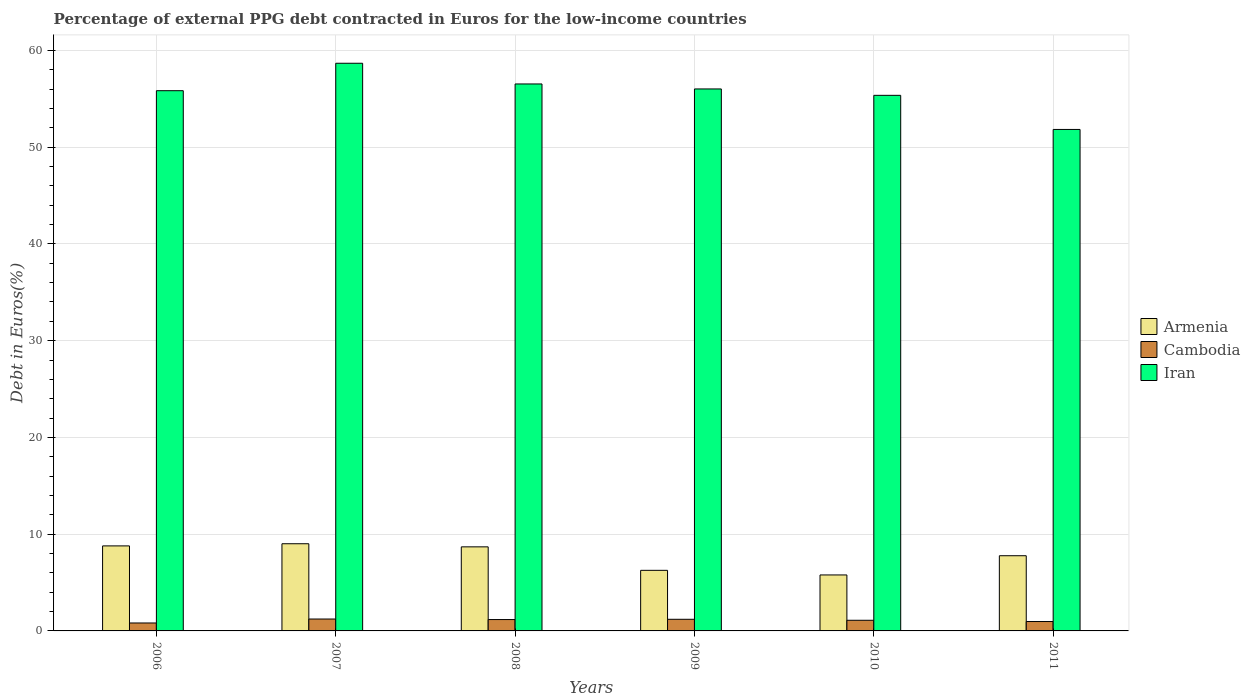How many groups of bars are there?
Give a very brief answer. 6. Are the number of bars per tick equal to the number of legend labels?
Provide a succinct answer. Yes. Are the number of bars on each tick of the X-axis equal?
Ensure brevity in your answer.  Yes. How many bars are there on the 6th tick from the right?
Ensure brevity in your answer.  3. What is the label of the 2nd group of bars from the left?
Provide a succinct answer. 2007. In how many cases, is the number of bars for a given year not equal to the number of legend labels?
Your response must be concise. 0. What is the percentage of external PPG debt contracted in Euros in Armenia in 2007?
Provide a succinct answer. 9.01. Across all years, what is the maximum percentage of external PPG debt contracted in Euros in Iran?
Give a very brief answer. 58.67. Across all years, what is the minimum percentage of external PPG debt contracted in Euros in Armenia?
Offer a terse response. 5.78. What is the total percentage of external PPG debt contracted in Euros in Iran in the graph?
Your answer should be compact. 334.23. What is the difference between the percentage of external PPG debt contracted in Euros in Cambodia in 2006 and that in 2007?
Your response must be concise. -0.41. What is the difference between the percentage of external PPG debt contracted in Euros in Cambodia in 2007 and the percentage of external PPG debt contracted in Euros in Iran in 2010?
Provide a succinct answer. -54.12. What is the average percentage of external PPG debt contracted in Euros in Armenia per year?
Keep it short and to the point. 7.72. In the year 2011, what is the difference between the percentage of external PPG debt contracted in Euros in Armenia and percentage of external PPG debt contracted in Euros in Iran?
Offer a very short reply. -44.06. What is the ratio of the percentage of external PPG debt contracted in Euros in Iran in 2008 to that in 2009?
Make the answer very short. 1.01. Is the difference between the percentage of external PPG debt contracted in Euros in Armenia in 2008 and 2011 greater than the difference between the percentage of external PPG debt contracted in Euros in Iran in 2008 and 2011?
Keep it short and to the point. No. What is the difference between the highest and the second highest percentage of external PPG debt contracted in Euros in Armenia?
Keep it short and to the point. 0.22. What is the difference between the highest and the lowest percentage of external PPG debt contracted in Euros in Iran?
Offer a terse response. 6.84. In how many years, is the percentage of external PPG debt contracted in Euros in Iran greater than the average percentage of external PPG debt contracted in Euros in Iran taken over all years?
Ensure brevity in your answer.  4. What does the 1st bar from the left in 2009 represents?
Your answer should be compact. Armenia. What does the 1st bar from the right in 2006 represents?
Keep it short and to the point. Iran. How many years are there in the graph?
Ensure brevity in your answer.  6. Are the values on the major ticks of Y-axis written in scientific E-notation?
Offer a terse response. No. Does the graph contain any zero values?
Your answer should be compact. No. How many legend labels are there?
Provide a short and direct response. 3. What is the title of the graph?
Your answer should be compact. Percentage of external PPG debt contracted in Euros for the low-income countries. What is the label or title of the X-axis?
Your answer should be very brief. Years. What is the label or title of the Y-axis?
Offer a terse response. Debt in Euros(%). What is the Debt in Euros(%) of Armenia in 2006?
Provide a succinct answer. 8.79. What is the Debt in Euros(%) in Cambodia in 2006?
Make the answer very short. 0.82. What is the Debt in Euros(%) in Iran in 2006?
Ensure brevity in your answer.  55.83. What is the Debt in Euros(%) of Armenia in 2007?
Ensure brevity in your answer.  9.01. What is the Debt in Euros(%) in Cambodia in 2007?
Give a very brief answer. 1.23. What is the Debt in Euros(%) in Iran in 2007?
Make the answer very short. 58.67. What is the Debt in Euros(%) of Armenia in 2008?
Give a very brief answer. 8.69. What is the Debt in Euros(%) of Cambodia in 2008?
Ensure brevity in your answer.  1.18. What is the Debt in Euros(%) in Iran in 2008?
Provide a short and direct response. 56.53. What is the Debt in Euros(%) in Armenia in 2009?
Offer a terse response. 6.26. What is the Debt in Euros(%) of Cambodia in 2009?
Keep it short and to the point. 1.2. What is the Debt in Euros(%) in Iran in 2009?
Make the answer very short. 56.01. What is the Debt in Euros(%) of Armenia in 2010?
Provide a succinct answer. 5.78. What is the Debt in Euros(%) in Cambodia in 2010?
Make the answer very short. 1.1. What is the Debt in Euros(%) of Iran in 2010?
Give a very brief answer. 55.35. What is the Debt in Euros(%) of Armenia in 2011?
Give a very brief answer. 7.77. What is the Debt in Euros(%) in Cambodia in 2011?
Keep it short and to the point. 0.97. What is the Debt in Euros(%) of Iran in 2011?
Offer a very short reply. 51.83. Across all years, what is the maximum Debt in Euros(%) in Armenia?
Offer a very short reply. 9.01. Across all years, what is the maximum Debt in Euros(%) of Cambodia?
Keep it short and to the point. 1.23. Across all years, what is the maximum Debt in Euros(%) in Iran?
Your answer should be compact. 58.67. Across all years, what is the minimum Debt in Euros(%) of Armenia?
Keep it short and to the point. 5.78. Across all years, what is the minimum Debt in Euros(%) in Cambodia?
Your answer should be very brief. 0.82. Across all years, what is the minimum Debt in Euros(%) of Iran?
Give a very brief answer. 51.83. What is the total Debt in Euros(%) in Armenia in the graph?
Provide a short and direct response. 46.31. What is the total Debt in Euros(%) in Cambodia in the graph?
Ensure brevity in your answer.  6.5. What is the total Debt in Euros(%) in Iran in the graph?
Give a very brief answer. 334.23. What is the difference between the Debt in Euros(%) in Armenia in 2006 and that in 2007?
Provide a short and direct response. -0.22. What is the difference between the Debt in Euros(%) of Cambodia in 2006 and that in 2007?
Provide a short and direct response. -0.41. What is the difference between the Debt in Euros(%) of Iran in 2006 and that in 2007?
Make the answer very short. -2.84. What is the difference between the Debt in Euros(%) of Armenia in 2006 and that in 2008?
Offer a terse response. 0.1. What is the difference between the Debt in Euros(%) in Cambodia in 2006 and that in 2008?
Your response must be concise. -0.35. What is the difference between the Debt in Euros(%) of Iran in 2006 and that in 2008?
Ensure brevity in your answer.  -0.7. What is the difference between the Debt in Euros(%) in Armenia in 2006 and that in 2009?
Provide a succinct answer. 2.53. What is the difference between the Debt in Euros(%) of Cambodia in 2006 and that in 2009?
Your answer should be very brief. -0.38. What is the difference between the Debt in Euros(%) of Iran in 2006 and that in 2009?
Ensure brevity in your answer.  -0.18. What is the difference between the Debt in Euros(%) of Armenia in 2006 and that in 2010?
Provide a short and direct response. 3. What is the difference between the Debt in Euros(%) of Cambodia in 2006 and that in 2010?
Your answer should be very brief. -0.28. What is the difference between the Debt in Euros(%) in Iran in 2006 and that in 2010?
Keep it short and to the point. 0.48. What is the difference between the Debt in Euros(%) of Armenia in 2006 and that in 2011?
Offer a very short reply. 1.02. What is the difference between the Debt in Euros(%) in Cambodia in 2006 and that in 2011?
Ensure brevity in your answer.  -0.15. What is the difference between the Debt in Euros(%) in Iran in 2006 and that in 2011?
Ensure brevity in your answer.  4.01. What is the difference between the Debt in Euros(%) of Armenia in 2007 and that in 2008?
Your response must be concise. 0.32. What is the difference between the Debt in Euros(%) of Cambodia in 2007 and that in 2008?
Provide a succinct answer. 0.05. What is the difference between the Debt in Euros(%) in Iran in 2007 and that in 2008?
Provide a short and direct response. 2.14. What is the difference between the Debt in Euros(%) of Armenia in 2007 and that in 2009?
Your answer should be very brief. 2.75. What is the difference between the Debt in Euros(%) of Cambodia in 2007 and that in 2009?
Provide a succinct answer. 0.03. What is the difference between the Debt in Euros(%) in Iran in 2007 and that in 2009?
Provide a short and direct response. 2.66. What is the difference between the Debt in Euros(%) of Armenia in 2007 and that in 2010?
Offer a very short reply. 3.23. What is the difference between the Debt in Euros(%) in Cambodia in 2007 and that in 2010?
Provide a short and direct response. 0.13. What is the difference between the Debt in Euros(%) in Iran in 2007 and that in 2010?
Your answer should be compact. 3.32. What is the difference between the Debt in Euros(%) in Armenia in 2007 and that in 2011?
Offer a terse response. 1.24. What is the difference between the Debt in Euros(%) of Cambodia in 2007 and that in 2011?
Make the answer very short. 0.26. What is the difference between the Debt in Euros(%) of Iran in 2007 and that in 2011?
Keep it short and to the point. 6.84. What is the difference between the Debt in Euros(%) of Armenia in 2008 and that in 2009?
Ensure brevity in your answer.  2.43. What is the difference between the Debt in Euros(%) of Cambodia in 2008 and that in 2009?
Keep it short and to the point. -0.03. What is the difference between the Debt in Euros(%) in Iran in 2008 and that in 2009?
Your response must be concise. 0.52. What is the difference between the Debt in Euros(%) of Armenia in 2008 and that in 2010?
Your answer should be very brief. 2.9. What is the difference between the Debt in Euros(%) in Cambodia in 2008 and that in 2010?
Provide a short and direct response. 0.07. What is the difference between the Debt in Euros(%) of Iran in 2008 and that in 2010?
Your answer should be compact. 1.18. What is the difference between the Debt in Euros(%) of Armenia in 2008 and that in 2011?
Ensure brevity in your answer.  0.92. What is the difference between the Debt in Euros(%) of Cambodia in 2008 and that in 2011?
Your response must be concise. 0.2. What is the difference between the Debt in Euros(%) of Iran in 2008 and that in 2011?
Ensure brevity in your answer.  4.7. What is the difference between the Debt in Euros(%) of Armenia in 2009 and that in 2010?
Your response must be concise. 0.48. What is the difference between the Debt in Euros(%) in Cambodia in 2009 and that in 2010?
Provide a short and direct response. 0.1. What is the difference between the Debt in Euros(%) in Iran in 2009 and that in 2010?
Offer a terse response. 0.66. What is the difference between the Debt in Euros(%) of Armenia in 2009 and that in 2011?
Provide a short and direct response. -1.51. What is the difference between the Debt in Euros(%) in Cambodia in 2009 and that in 2011?
Offer a very short reply. 0.23. What is the difference between the Debt in Euros(%) in Iran in 2009 and that in 2011?
Ensure brevity in your answer.  4.19. What is the difference between the Debt in Euros(%) in Armenia in 2010 and that in 2011?
Offer a very short reply. -1.99. What is the difference between the Debt in Euros(%) in Cambodia in 2010 and that in 2011?
Provide a succinct answer. 0.13. What is the difference between the Debt in Euros(%) in Iran in 2010 and that in 2011?
Offer a very short reply. 3.53. What is the difference between the Debt in Euros(%) in Armenia in 2006 and the Debt in Euros(%) in Cambodia in 2007?
Keep it short and to the point. 7.56. What is the difference between the Debt in Euros(%) in Armenia in 2006 and the Debt in Euros(%) in Iran in 2007?
Offer a very short reply. -49.88. What is the difference between the Debt in Euros(%) in Cambodia in 2006 and the Debt in Euros(%) in Iran in 2007?
Ensure brevity in your answer.  -57.85. What is the difference between the Debt in Euros(%) in Armenia in 2006 and the Debt in Euros(%) in Cambodia in 2008?
Your answer should be compact. 7.61. What is the difference between the Debt in Euros(%) in Armenia in 2006 and the Debt in Euros(%) in Iran in 2008?
Provide a succinct answer. -47.74. What is the difference between the Debt in Euros(%) of Cambodia in 2006 and the Debt in Euros(%) of Iran in 2008?
Offer a very short reply. -55.71. What is the difference between the Debt in Euros(%) in Armenia in 2006 and the Debt in Euros(%) in Cambodia in 2009?
Make the answer very short. 7.59. What is the difference between the Debt in Euros(%) in Armenia in 2006 and the Debt in Euros(%) in Iran in 2009?
Offer a terse response. -47.23. What is the difference between the Debt in Euros(%) of Cambodia in 2006 and the Debt in Euros(%) of Iran in 2009?
Your answer should be compact. -55.19. What is the difference between the Debt in Euros(%) in Armenia in 2006 and the Debt in Euros(%) in Cambodia in 2010?
Give a very brief answer. 7.69. What is the difference between the Debt in Euros(%) of Armenia in 2006 and the Debt in Euros(%) of Iran in 2010?
Make the answer very short. -46.57. What is the difference between the Debt in Euros(%) in Cambodia in 2006 and the Debt in Euros(%) in Iran in 2010?
Keep it short and to the point. -54.53. What is the difference between the Debt in Euros(%) of Armenia in 2006 and the Debt in Euros(%) of Cambodia in 2011?
Provide a short and direct response. 7.82. What is the difference between the Debt in Euros(%) in Armenia in 2006 and the Debt in Euros(%) in Iran in 2011?
Keep it short and to the point. -43.04. What is the difference between the Debt in Euros(%) of Cambodia in 2006 and the Debt in Euros(%) of Iran in 2011?
Give a very brief answer. -51.01. What is the difference between the Debt in Euros(%) in Armenia in 2007 and the Debt in Euros(%) in Cambodia in 2008?
Make the answer very short. 7.84. What is the difference between the Debt in Euros(%) in Armenia in 2007 and the Debt in Euros(%) in Iran in 2008?
Your response must be concise. -47.52. What is the difference between the Debt in Euros(%) of Cambodia in 2007 and the Debt in Euros(%) of Iran in 2008?
Make the answer very short. -55.3. What is the difference between the Debt in Euros(%) in Armenia in 2007 and the Debt in Euros(%) in Cambodia in 2009?
Your answer should be compact. 7.81. What is the difference between the Debt in Euros(%) of Armenia in 2007 and the Debt in Euros(%) of Iran in 2009?
Give a very brief answer. -47. What is the difference between the Debt in Euros(%) in Cambodia in 2007 and the Debt in Euros(%) in Iran in 2009?
Provide a succinct answer. -54.78. What is the difference between the Debt in Euros(%) in Armenia in 2007 and the Debt in Euros(%) in Cambodia in 2010?
Provide a short and direct response. 7.91. What is the difference between the Debt in Euros(%) in Armenia in 2007 and the Debt in Euros(%) in Iran in 2010?
Provide a short and direct response. -46.34. What is the difference between the Debt in Euros(%) of Cambodia in 2007 and the Debt in Euros(%) of Iran in 2010?
Your answer should be very brief. -54.12. What is the difference between the Debt in Euros(%) of Armenia in 2007 and the Debt in Euros(%) of Cambodia in 2011?
Provide a short and direct response. 8.04. What is the difference between the Debt in Euros(%) in Armenia in 2007 and the Debt in Euros(%) in Iran in 2011?
Provide a succinct answer. -42.82. What is the difference between the Debt in Euros(%) in Cambodia in 2007 and the Debt in Euros(%) in Iran in 2011?
Offer a very short reply. -50.6. What is the difference between the Debt in Euros(%) of Armenia in 2008 and the Debt in Euros(%) of Cambodia in 2009?
Your answer should be compact. 7.49. What is the difference between the Debt in Euros(%) in Armenia in 2008 and the Debt in Euros(%) in Iran in 2009?
Offer a very short reply. -47.33. What is the difference between the Debt in Euros(%) in Cambodia in 2008 and the Debt in Euros(%) in Iran in 2009?
Your answer should be compact. -54.84. What is the difference between the Debt in Euros(%) in Armenia in 2008 and the Debt in Euros(%) in Cambodia in 2010?
Your answer should be very brief. 7.59. What is the difference between the Debt in Euros(%) of Armenia in 2008 and the Debt in Euros(%) of Iran in 2010?
Offer a very short reply. -46.67. What is the difference between the Debt in Euros(%) in Cambodia in 2008 and the Debt in Euros(%) in Iran in 2010?
Provide a succinct answer. -54.18. What is the difference between the Debt in Euros(%) in Armenia in 2008 and the Debt in Euros(%) in Cambodia in 2011?
Keep it short and to the point. 7.72. What is the difference between the Debt in Euros(%) in Armenia in 2008 and the Debt in Euros(%) in Iran in 2011?
Make the answer very short. -43.14. What is the difference between the Debt in Euros(%) in Cambodia in 2008 and the Debt in Euros(%) in Iran in 2011?
Your answer should be compact. -50.65. What is the difference between the Debt in Euros(%) of Armenia in 2009 and the Debt in Euros(%) of Cambodia in 2010?
Your response must be concise. 5.16. What is the difference between the Debt in Euros(%) of Armenia in 2009 and the Debt in Euros(%) of Iran in 2010?
Give a very brief answer. -49.09. What is the difference between the Debt in Euros(%) in Cambodia in 2009 and the Debt in Euros(%) in Iran in 2010?
Give a very brief answer. -54.15. What is the difference between the Debt in Euros(%) in Armenia in 2009 and the Debt in Euros(%) in Cambodia in 2011?
Offer a terse response. 5.29. What is the difference between the Debt in Euros(%) of Armenia in 2009 and the Debt in Euros(%) of Iran in 2011?
Provide a succinct answer. -45.57. What is the difference between the Debt in Euros(%) in Cambodia in 2009 and the Debt in Euros(%) in Iran in 2011?
Your answer should be compact. -50.63. What is the difference between the Debt in Euros(%) in Armenia in 2010 and the Debt in Euros(%) in Cambodia in 2011?
Your response must be concise. 4.81. What is the difference between the Debt in Euros(%) in Armenia in 2010 and the Debt in Euros(%) in Iran in 2011?
Make the answer very short. -46.04. What is the difference between the Debt in Euros(%) of Cambodia in 2010 and the Debt in Euros(%) of Iran in 2011?
Offer a terse response. -50.73. What is the average Debt in Euros(%) of Armenia per year?
Provide a succinct answer. 7.72. What is the average Debt in Euros(%) of Cambodia per year?
Keep it short and to the point. 1.08. What is the average Debt in Euros(%) in Iran per year?
Keep it short and to the point. 55.7. In the year 2006, what is the difference between the Debt in Euros(%) in Armenia and Debt in Euros(%) in Cambodia?
Provide a succinct answer. 7.97. In the year 2006, what is the difference between the Debt in Euros(%) of Armenia and Debt in Euros(%) of Iran?
Your answer should be very brief. -47.05. In the year 2006, what is the difference between the Debt in Euros(%) of Cambodia and Debt in Euros(%) of Iran?
Make the answer very short. -55.01. In the year 2007, what is the difference between the Debt in Euros(%) of Armenia and Debt in Euros(%) of Cambodia?
Give a very brief answer. 7.78. In the year 2007, what is the difference between the Debt in Euros(%) of Armenia and Debt in Euros(%) of Iran?
Offer a very short reply. -49.66. In the year 2007, what is the difference between the Debt in Euros(%) in Cambodia and Debt in Euros(%) in Iran?
Provide a short and direct response. -57.44. In the year 2008, what is the difference between the Debt in Euros(%) in Armenia and Debt in Euros(%) in Cambodia?
Make the answer very short. 7.51. In the year 2008, what is the difference between the Debt in Euros(%) of Armenia and Debt in Euros(%) of Iran?
Keep it short and to the point. -47.84. In the year 2008, what is the difference between the Debt in Euros(%) in Cambodia and Debt in Euros(%) in Iran?
Offer a terse response. -55.36. In the year 2009, what is the difference between the Debt in Euros(%) in Armenia and Debt in Euros(%) in Cambodia?
Your response must be concise. 5.06. In the year 2009, what is the difference between the Debt in Euros(%) in Armenia and Debt in Euros(%) in Iran?
Your answer should be very brief. -49.75. In the year 2009, what is the difference between the Debt in Euros(%) of Cambodia and Debt in Euros(%) of Iran?
Provide a succinct answer. -54.81. In the year 2010, what is the difference between the Debt in Euros(%) in Armenia and Debt in Euros(%) in Cambodia?
Provide a succinct answer. 4.68. In the year 2010, what is the difference between the Debt in Euros(%) in Armenia and Debt in Euros(%) in Iran?
Offer a very short reply. -49.57. In the year 2010, what is the difference between the Debt in Euros(%) of Cambodia and Debt in Euros(%) of Iran?
Give a very brief answer. -54.25. In the year 2011, what is the difference between the Debt in Euros(%) of Armenia and Debt in Euros(%) of Cambodia?
Your answer should be very brief. 6.8. In the year 2011, what is the difference between the Debt in Euros(%) of Armenia and Debt in Euros(%) of Iran?
Your response must be concise. -44.06. In the year 2011, what is the difference between the Debt in Euros(%) of Cambodia and Debt in Euros(%) of Iran?
Keep it short and to the point. -50.86. What is the ratio of the Debt in Euros(%) of Armenia in 2006 to that in 2007?
Offer a very short reply. 0.98. What is the ratio of the Debt in Euros(%) in Cambodia in 2006 to that in 2007?
Provide a short and direct response. 0.67. What is the ratio of the Debt in Euros(%) in Iran in 2006 to that in 2007?
Provide a succinct answer. 0.95. What is the ratio of the Debt in Euros(%) in Armenia in 2006 to that in 2008?
Your answer should be compact. 1.01. What is the ratio of the Debt in Euros(%) of Cambodia in 2006 to that in 2008?
Ensure brevity in your answer.  0.7. What is the ratio of the Debt in Euros(%) of Iran in 2006 to that in 2008?
Your answer should be compact. 0.99. What is the ratio of the Debt in Euros(%) in Armenia in 2006 to that in 2009?
Ensure brevity in your answer.  1.4. What is the ratio of the Debt in Euros(%) of Cambodia in 2006 to that in 2009?
Ensure brevity in your answer.  0.68. What is the ratio of the Debt in Euros(%) in Iran in 2006 to that in 2009?
Make the answer very short. 1. What is the ratio of the Debt in Euros(%) of Armenia in 2006 to that in 2010?
Provide a succinct answer. 1.52. What is the ratio of the Debt in Euros(%) of Cambodia in 2006 to that in 2010?
Provide a short and direct response. 0.75. What is the ratio of the Debt in Euros(%) in Iran in 2006 to that in 2010?
Ensure brevity in your answer.  1.01. What is the ratio of the Debt in Euros(%) in Armenia in 2006 to that in 2011?
Provide a short and direct response. 1.13. What is the ratio of the Debt in Euros(%) in Cambodia in 2006 to that in 2011?
Your answer should be very brief. 0.85. What is the ratio of the Debt in Euros(%) of Iran in 2006 to that in 2011?
Offer a terse response. 1.08. What is the ratio of the Debt in Euros(%) in Armenia in 2007 to that in 2008?
Offer a very short reply. 1.04. What is the ratio of the Debt in Euros(%) of Cambodia in 2007 to that in 2008?
Your response must be concise. 1.05. What is the ratio of the Debt in Euros(%) in Iran in 2007 to that in 2008?
Your answer should be compact. 1.04. What is the ratio of the Debt in Euros(%) in Armenia in 2007 to that in 2009?
Your answer should be very brief. 1.44. What is the ratio of the Debt in Euros(%) of Cambodia in 2007 to that in 2009?
Provide a short and direct response. 1.02. What is the ratio of the Debt in Euros(%) in Iran in 2007 to that in 2009?
Offer a very short reply. 1.05. What is the ratio of the Debt in Euros(%) in Armenia in 2007 to that in 2010?
Offer a terse response. 1.56. What is the ratio of the Debt in Euros(%) of Cambodia in 2007 to that in 2010?
Provide a short and direct response. 1.12. What is the ratio of the Debt in Euros(%) of Iran in 2007 to that in 2010?
Give a very brief answer. 1.06. What is the ratio of the Debt in Euros(%) in Armenia in 2007 to that in 2011?
Your answer should be compact. 1.16. What is the ratio of the Debt in Euros(%) of Cambodia in 2007 to that in 2011?
Give a very brief answer. 1.27. What is the ratio of the Debt in Euros(%) in Iran in 2007 to that in 2011?
Ensure brevity in your answer.  1.13. What is the ratio of the Debt in Euros(%) in Armenia in 2008 to that in 2009?
Provide a succinct answer. 1.39. What is the ratio of the Debt in Euros(%) in Cambodia in 2008 to that in 2009?
Offer a terse response. 0.98. What is the ratio of the Debt in Euros(%) in Iran in 2008 to that in 2009?
Your answer should be very brief. 1.01. What is the ratio of the Debt in Euros(%) of Armenia in 2008 to that in 2010?
Provide a succinct answer. 1.5. What is the ratio of the Debt in Euros(%) of Cambodia in 2008 to that in 2010?
Provide a succinct answer. 1.07. What is the ratio of the Debt in Euros(%) of Iran in 2008 to that in 2010?
Give a very brief answer. 1.02. What is the ratio of the Debt in Euros(%) in Armenia in 2008 to that in 2011?
Provide a short and direct response. 1.12. What is the ratio of the Debt in Euros(%) in Cambodia in 2008 to that in 2011?
Keep it short and to the point. 1.21. What is the ratio of the Debt in Euros(%) of Iran in 2008 to that in 2011?
Your answer should be very brief. 1.09. What is the ratio of the Debt in Euros(%) of Armenia in 2009 to that in 2010?
Your answer should be very brief. 1.08. What is the ratio of the Debt in Euros(%) in Cambodia in 2009 to that in 2010?
Your answer should be very brief. 1.09. What is the ratio of the Debt in Euros(%) of Iran in 2009 to that in 2010?
Provide a succinct answer. 1.01. What is the ratio of the Debt in Euros(%) of Armenia in 2009 to that in 2011?
Make the answer very short. 0.81. What is the ratio of the Debt in Euros(%) in Cambodia in 2009 to that in 2011?
Offer a terse response. 1.24. What is the ratio of the Debt in Euros(%) of Iran in 2009 to that in 2011?
Keep it short and to the point. 1.08. What is the ratio of the Debt in Euros(%) of Armenia in 2010 to that in 2011?
Provide a short and direct response. 0.74. What is the ratio of the Debt in Euros(%) in Cambodia in 2010 to that in 2011?
Your answer should be compact. 1.13. What is the ratio of the Debt in Euros(%) of Iran in 2010 to that in 2011?
Provide a succinct answer. 1.07. What is the difference between the highest and the second highest Debt in Euros(%) in Armenia?
Keep it short and to the point. 0.22. What is the difference between the highest and the second highest Debt in Euros(%) of Cambodia?
Keep it short and to the point. 0.03. What is the difference between the highest and the second highest Debt in Euros(%) of Iran?
Your answer should be compact. 2.14. What is the difference between the highest and the lowest Debt in Euros(%) of Armenia?
Offer a terse response. 3.23. What is the difference between the highest and the lowest Debt in Euros(%) in Cambodia?
Offer a terse response. 0.41. What is the difference between the highest and the lowest Debt in Euros(%) of Iran?
Give a very brief answer. 6.84. 